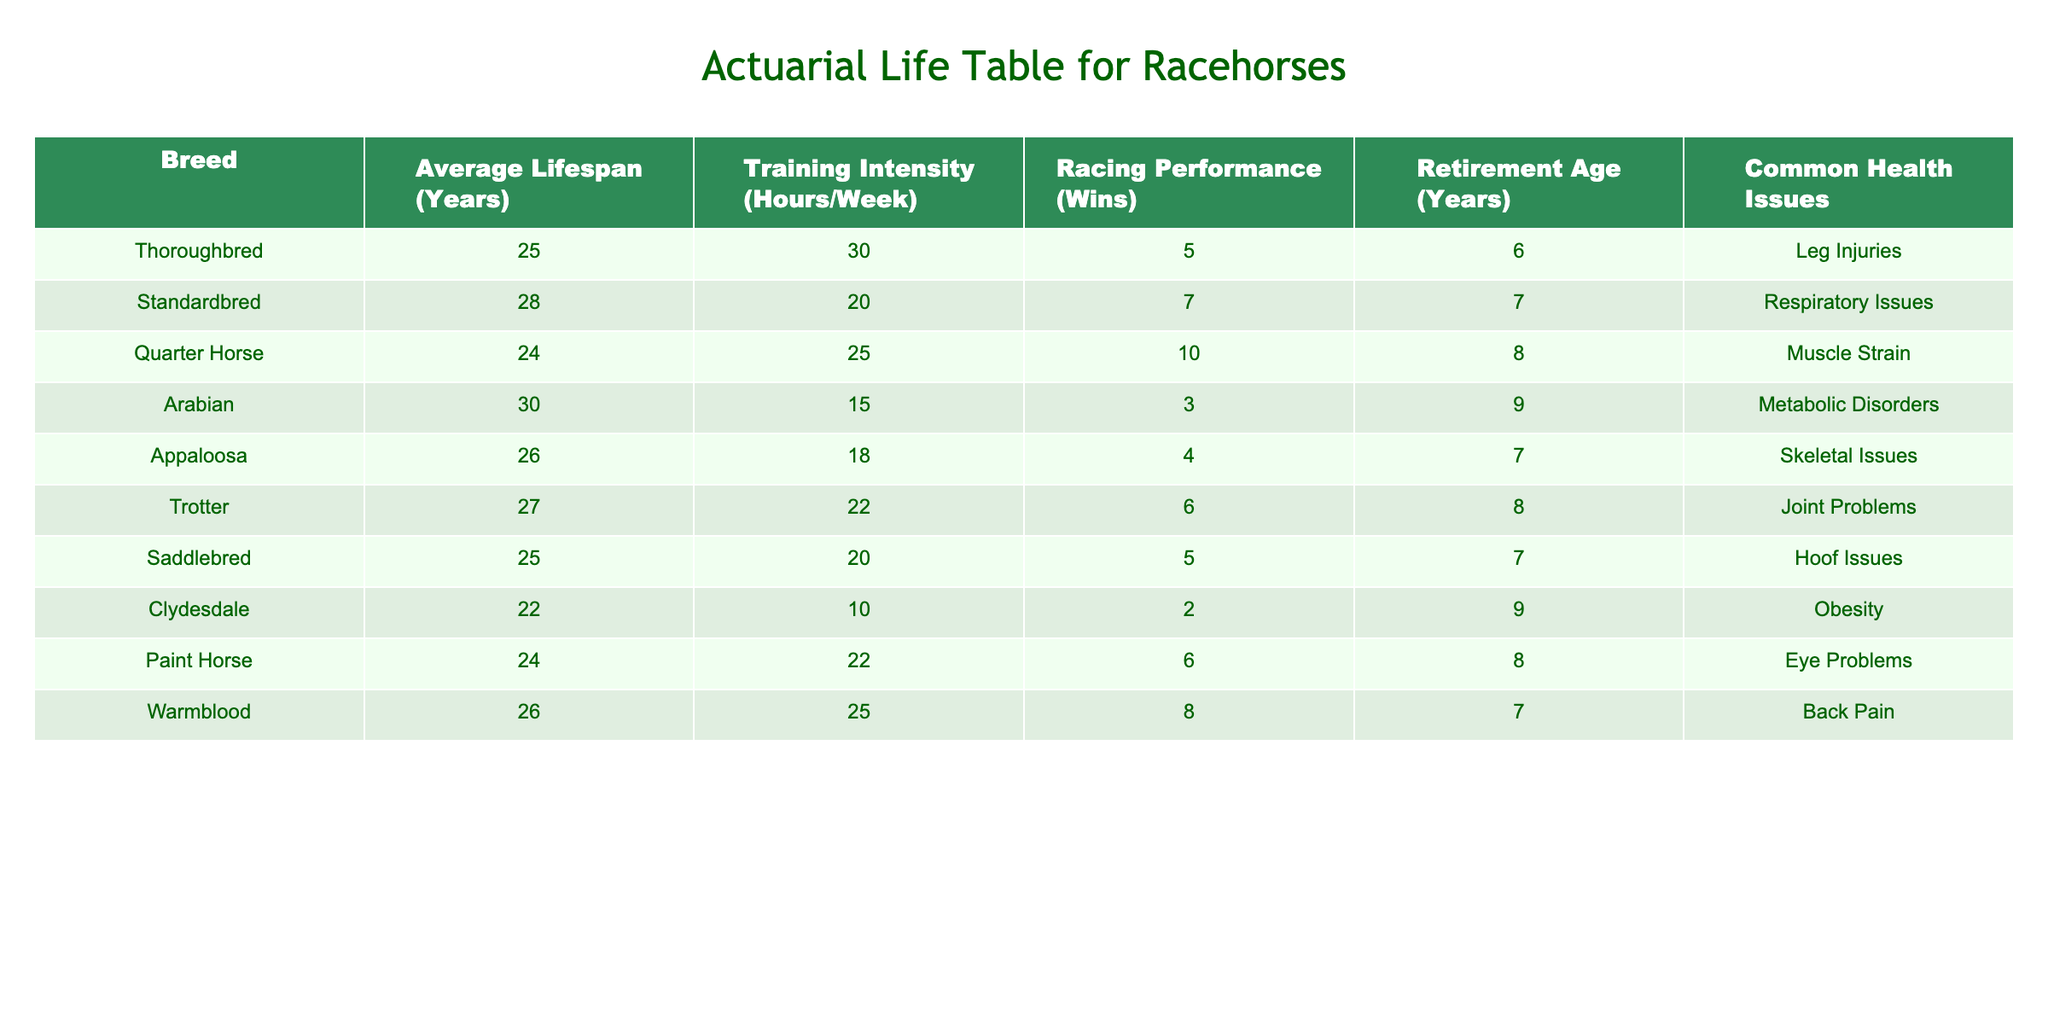What is the average lifespan of Thoroughbreds? The table indicates that the average lifespan of Thoroughbreds is listed as 25 years.
Answer: 25 years Which breed has the longest average lifespan among the listed breeds? By comparing the average lifespans of all the breeds in the table, Arabian horses have the longest average lifespan at 30 years.
Answer: Arabian Do Standardbreds have a higher average lifespan than Quarter Horses? The average lifespan for Standardbreds is 28 years and for Quarter Horses, it is 24 years. Since 28 is greater than 24, the answer is yes.
Answer: Yes What is the average training intensity (hours/week) for Appaloosas and Quarter Horses combined? The training intensity for Appaloosas is 18 hours/week and for Quarter Horses is 25 hours/week. Adding these values, we get 18 + 25 = 43 hours/week. To find the average, we divide it by 2, so 43/2 = 21.5 hours/week.
Answer: 21.5 hours/week Is it true that all breeds listed have a retirement age of at least 6 years? Reviewing the retirement ages, thoroughbred horses retire at 6 years, while Clydesdales retire at 9 years. Therefore, since at least one breed, Thoroughbred, has a retirement age of exactly 6 years, the statement is true.
Answer: True What is the total number of wins for Arabian and Appaloosa horses? The wins for Arabians is 3 and for Appaloosas it is 4. Adding these, we have 3 + 4 = 7 wins in total.
Answer: 7 wins Which breed is most likely to suffer from skeletal issues? Looking at the health issues column, the breed associated with skeletal issues is Appaloosa.
Answer: Appaloosa How many breeds have a training intensity of 20 hours/week or less? From the table, the breeds with 20 hours/week of training intensity or less are Standardbred (20), Clydesdale (10), and Saddlebred (20). This totals 3 breeds.
Answer: 3 breeds What is the difference in retirement ages between Thoroughbreds and Warmbloods? The retirement age for Thoroughbreds is 6 years and for Warmbloods is 7 years. The difference is 7 - 6 = 1 year.
Answer: 1 year 